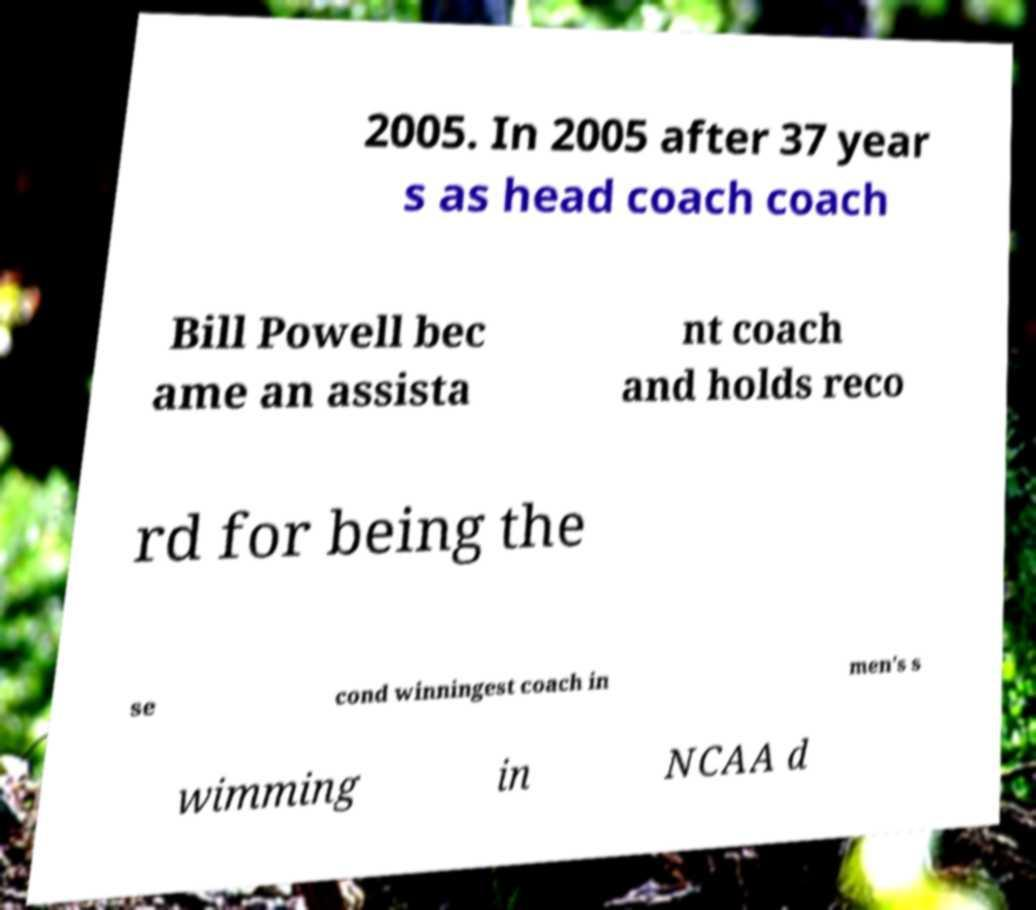What messages or text are displayed in this image? I need them in a readable, typed format. 2005. In 2005 after 37 year s as head coach coach Bill Powell bec ame an assista nt coach and holds reco rd for being the se cond winningest coach in men's s wimming in NCAA d 